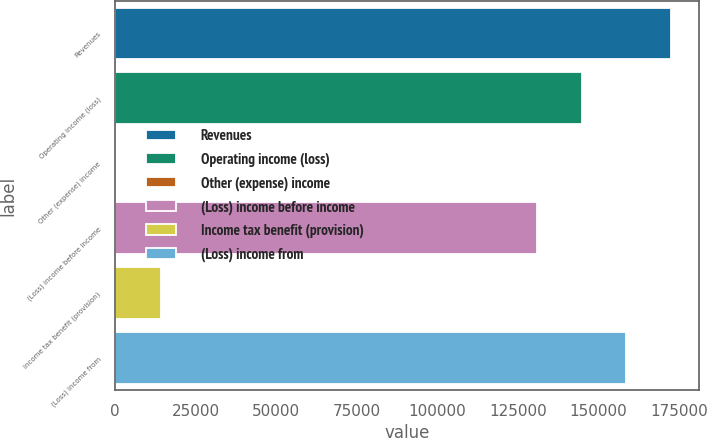Convert chart to OTSL. <chart><loc_0><loc_0><loc_500><loc_500><bar_chart><fcel>Revenues<fcel>Operating income (loss)<fcel>Other (expense) income<fcel>(Loss) income before income<fcel>Income tax benefit (provision)<fcel>(Loss) income from<nl><fcel>172525<fcel>144736<fcel>275<fcel>130842<fcel>14169.3<fcel>158631<nl></chart> 